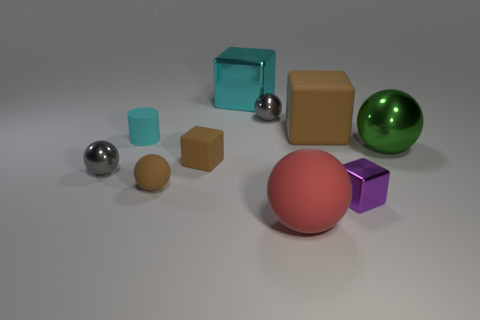Subtract all green balls. How many balls are left? 4 Subtract all green blocks. How many gray spheres are left? 2 Subtract all red balls. How many balls are left? 4 Subtract all red spheres. Subtract all cyan blocks. How many spheres are left? 4 Subtract all gray things. Subtract all red things. How many objects are left? 7 Add 1 gray shiny things. How many gray shiny things are left? 3 Add 8 big rubber spheres. How many big rubber spheres exist? 9 Subtract 0 yellow cylinders. How many objects are left? 10 Subtract all blocks. How many objects are left? 6 